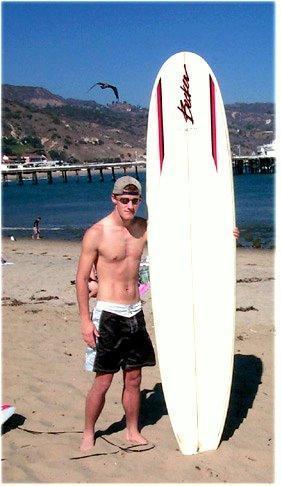How many birds are there?
Give a very brief answer. 1. 